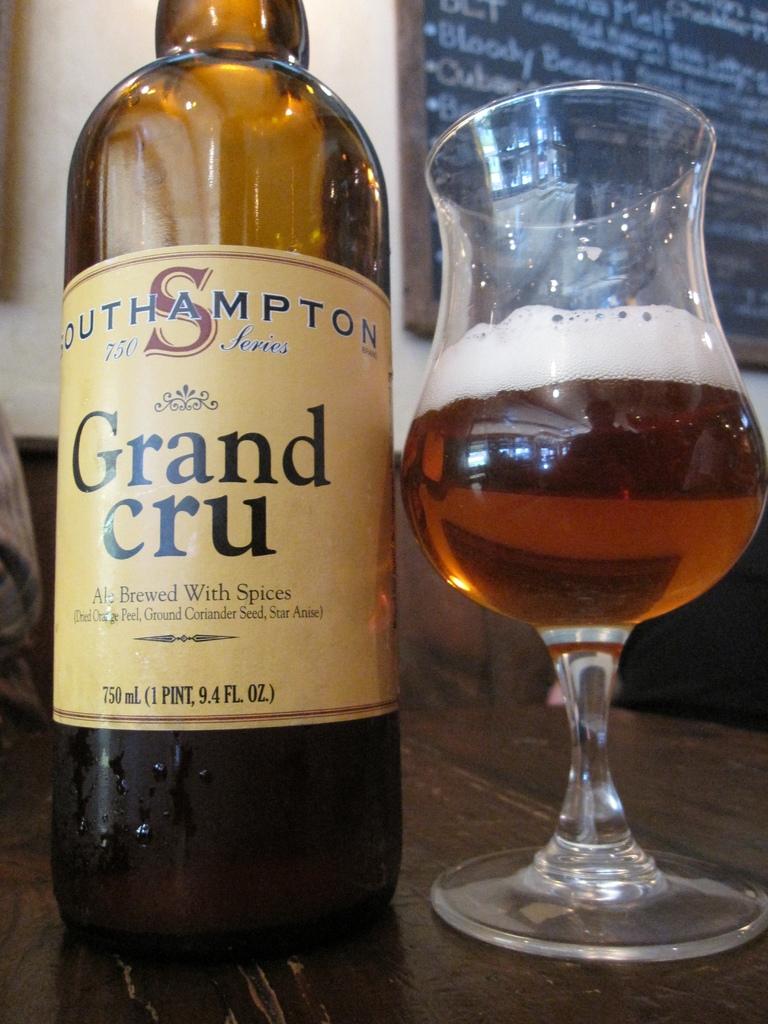How many fluid ounzes are in the bottle?
Your answer should be very brief. 9.4. What is the ale brewed with?
Your answer should be compact. Spices. 